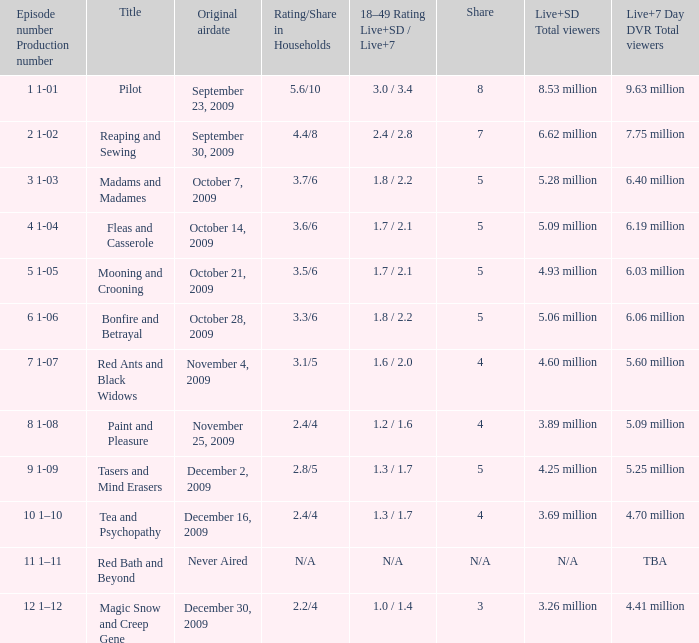69 million total viewers (live and sd types combined)? December 16, 2009. 